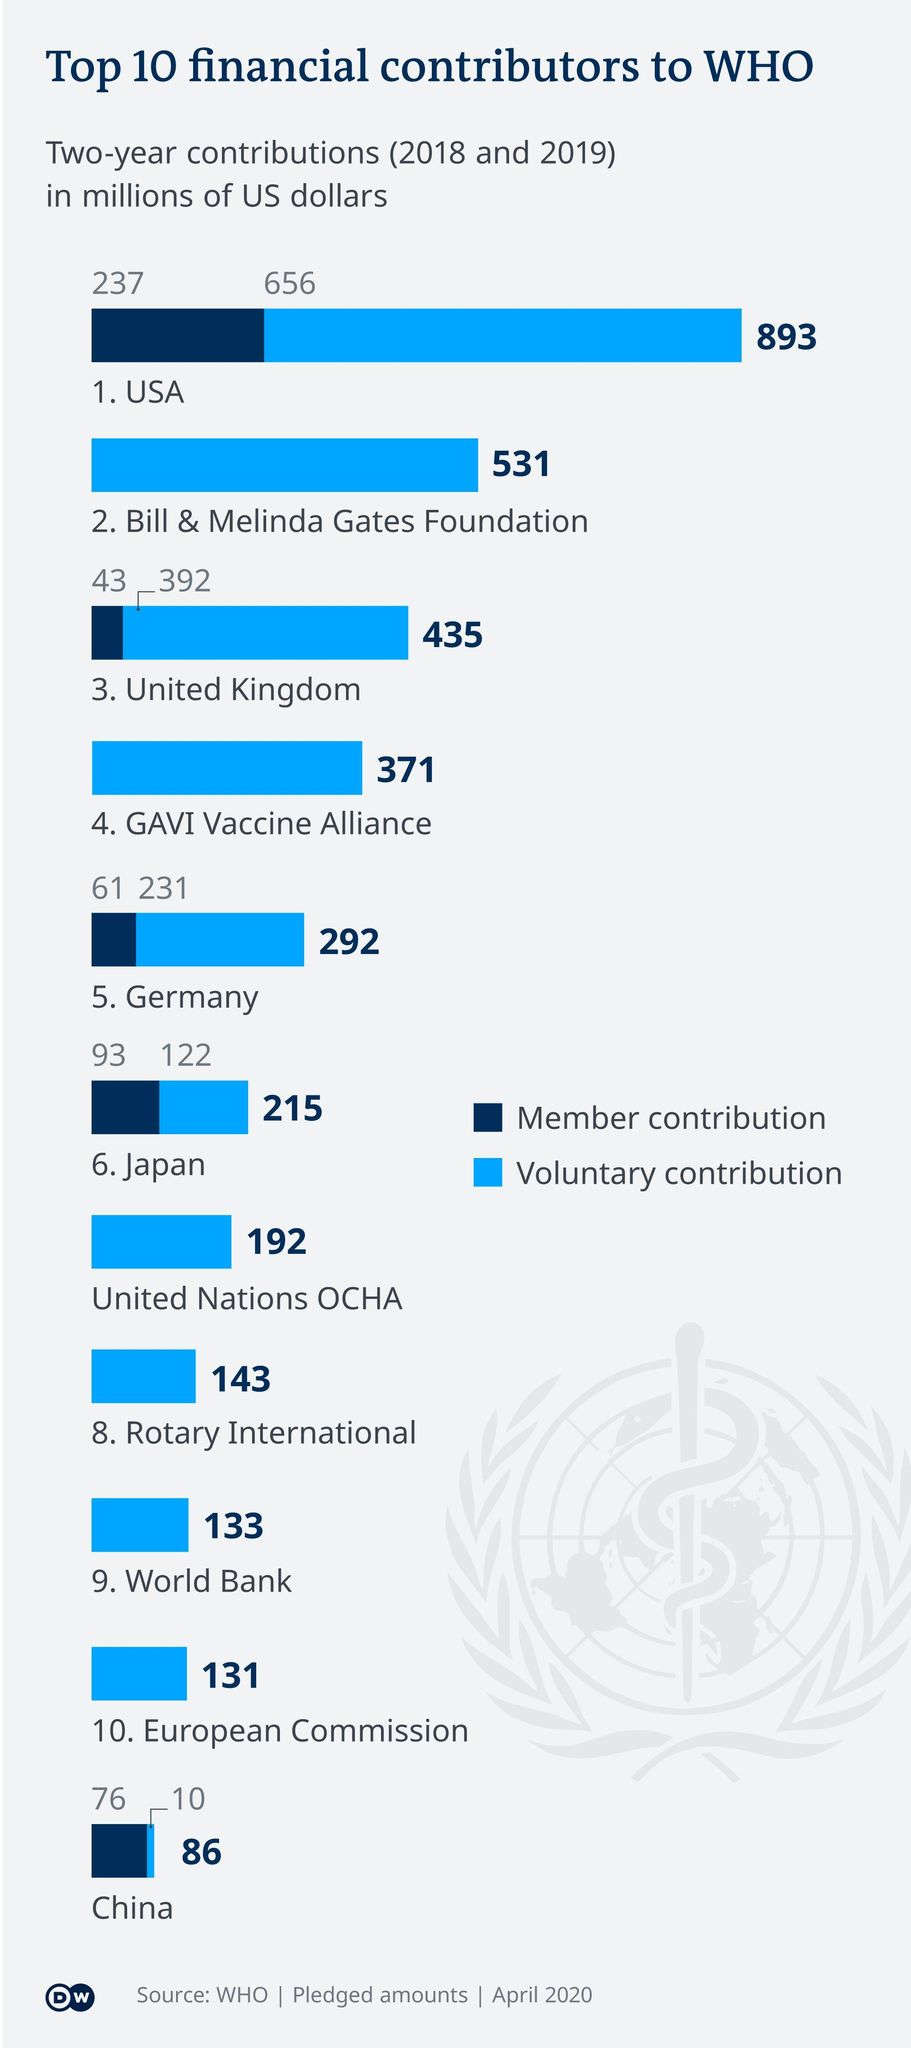What is the member contribution from Germany ($m)?
Answer the question with a short phrase. 61 What is China's contribution to WHO ($m) ? 86 By how much is the voluntary contribution in USA higher than member contribution ($m)? 419 What are the two types of contributions made? Member contribution, voluntary contribution By how much is the contribution of Rotary International higher than World Bank ($m)? 10 Who has made a higher voluntary contribution, United Kingdom or GAVI Vaccine Alliance? United Kingdom What is the voluntary contribution made by United Nations OCHA ($m)? 192 What is is Japan's contribution to WHO ($m)? 215 What is the voluntary contribution from Japan ($m)? 122 Which are the top 3 financial contributors to WHO ($m)? USA, Bill & Melinda Gates Foundation, United Kingdom What is the member contribution from United Kingdom($m)? 43 What is the member contribution made by China ($m) ? 76 Which are the last three contributors mentioned? World Bank, European commission, China What is the voluntary contribution made by China ($m)? 10 